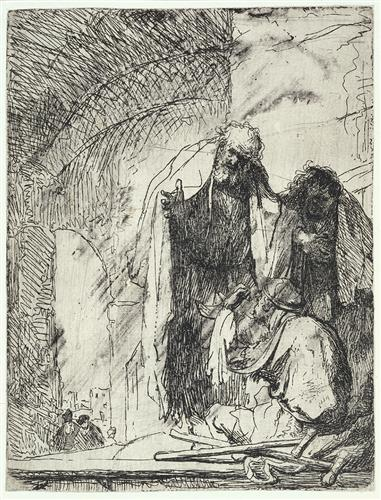What is this photo about'? The image depicts a scene set within a cavernous space, likely a church or temple, given the religious undertones. The space is filled with figures, each draped in robes, their postures and expressions suggesting a state of mourning. The art style is reminiscent of the Baroque period, characterized by its dramatic contrasts of light and dark, which serve to highlight the emotional intensity of the scene. The use of etching as a medium further enhances the depth and detail of the image, from the intricate folds of the robes to the architectural elements of the setting. Despite the somber mood, the image is rich in narrative, inviting viewers to contemplate the story behind the scene. 